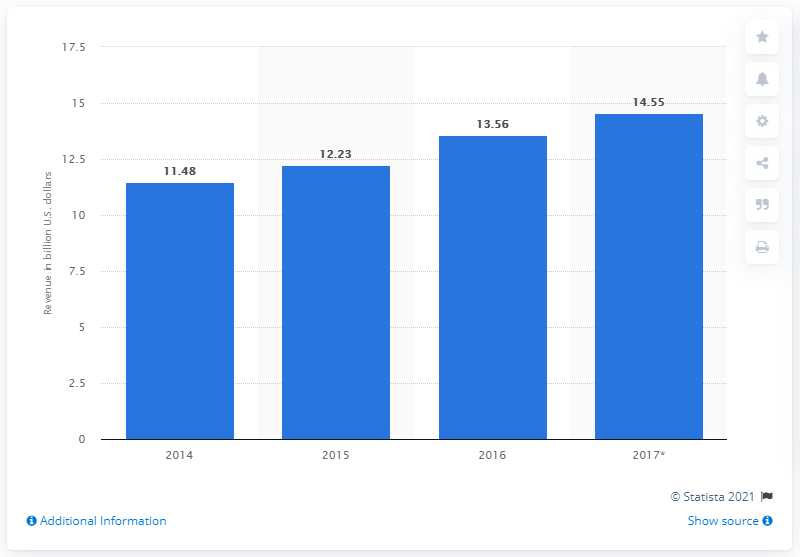Mention a couple of crucial points in this snapshot. In 2017, the market value of earphones and headphones was 14.55. 